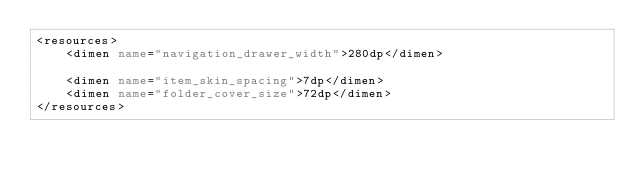Convert code to text. <code><loc_0><loc_0><loc_500><loc_500><_XML_><resources>
    <dimen name="navigation_drawer_width">280dp</dimen>

    <dimen name="item_skin_spacing">7dp</dimen>
    <dimen name="folder_cover_size">72dp</dimen>
</resources>
</code> 